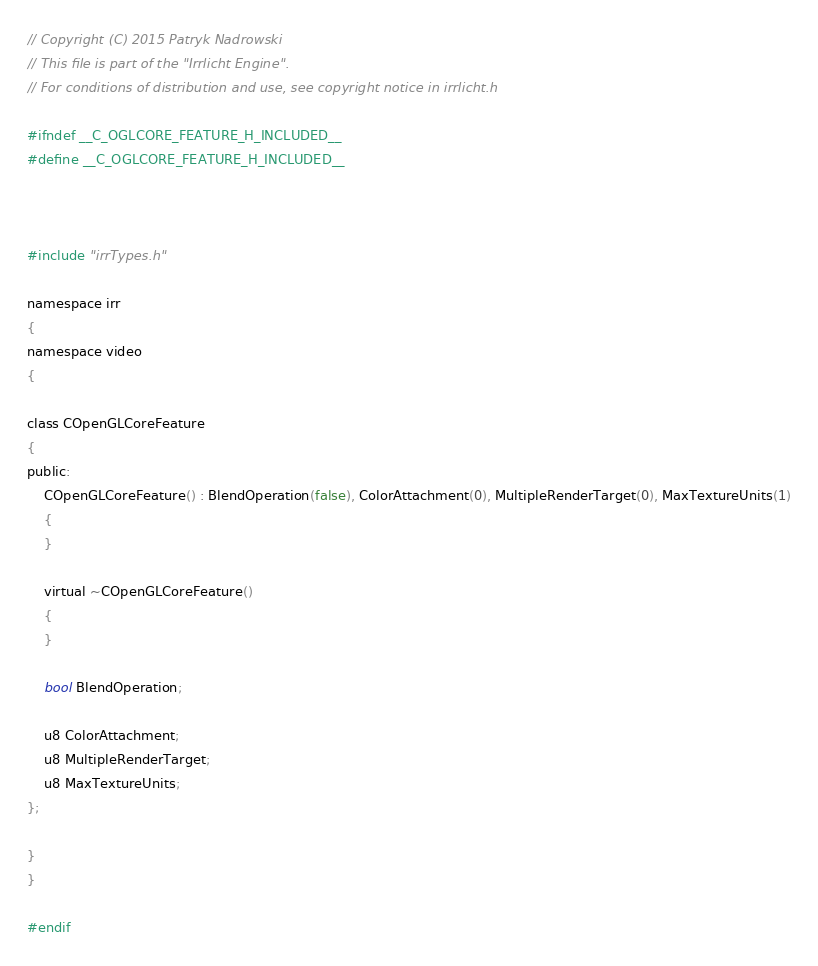<code> <loc_0><loc_0><loc_500><loc_500><_C_>// Copyright (C) 2015 Patryk Nadrowski
// This file is part of the "Irrlicht Engine".
// For conditions of distribution and use, see copyright notice in irrlicht.h

#ifndef __C_OGLCORE_FEATURE_H_INCLUDED__
#define __C_OGLCORE_FEATURE_H_INCLUDED__



#include "irrTypes.h"

namespace irr
{
namespace video
{

class COpenGLCoreFeature
{
public:
	COpenGLCoreFeature() : BlendOperation(false), ColorAttachment(0), MultipleRenderTarget(0), MaxTextureUnits(1)
	{
	}

	virtual ~COpenGLCoreFeature()
	{
	}

	bool BlendOperation;
	
	u8 ColorAttachment;
	u8 MultipleRenderTarget;
	u8 MaxTextureUnits;
};

}
}

#endif
</code> 